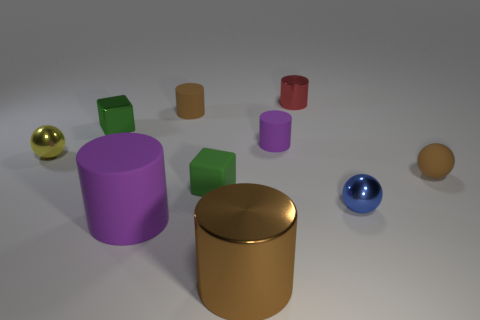Subtract all rubber spheres. How many spheres are left? 2 Subtract all blocks. How many objects are left? 8 Add 2 cyan shiny blocks. How many cyan shiny blocks exist? 2 Subtract all red cylinders. How many cylinders are left? 4 Subtract 1 brown cylinders. How many objects are left? 9 Subtract 4 cylinders. How many cylinders are left? 1 Subtract all blue blocks. Subtract all brown balls. How many blocks are left? 2 Subtract all red spheres. How many purple cylinders are left? 2 Subtract all tiny blue things. Subtract all brown rubber balls. How many objects are left? 8 Add 7 small matte cylinders. How many small matte cylinders are left? 9 